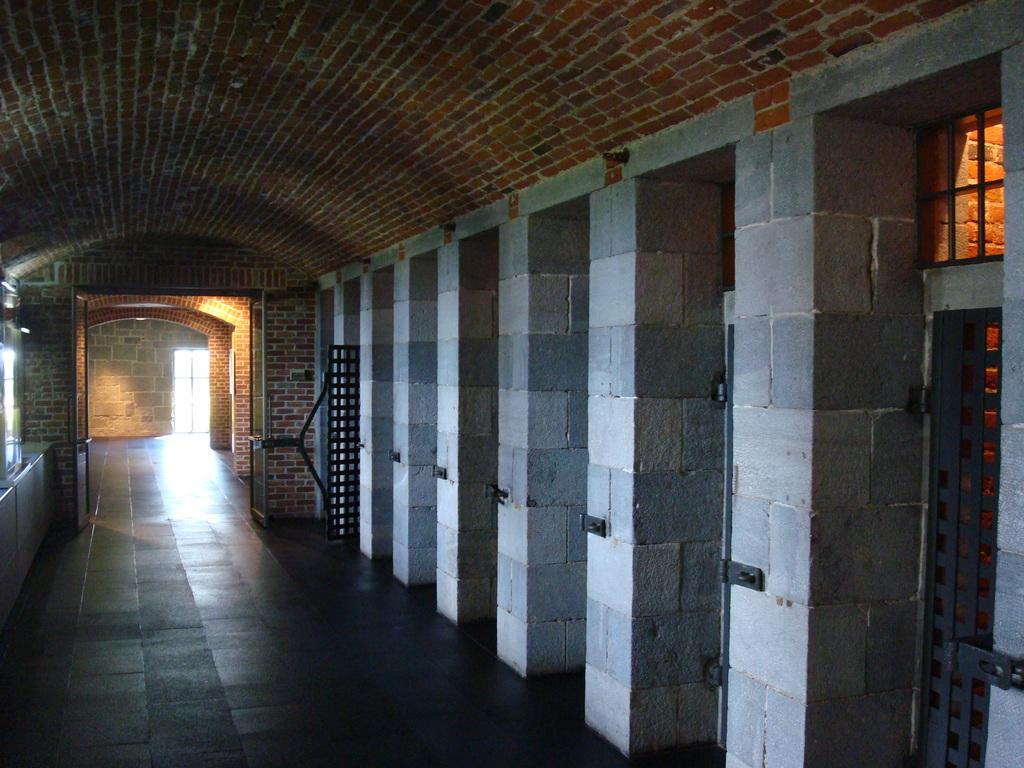Could you give a brief overview of what you see in this image? This is the inside picture of the building. On the right side of the image there are pillars. There is a metal fence. On the left side of the image there are windows. In the center of the image there is a open door. In the background of the image there is a wall. There is a glass door. At the bottom of the image there is a floor. 